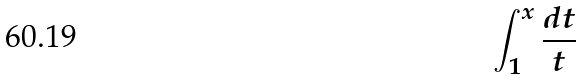Convert formula to latex. <formula><loc_0><loc_0><loc_500><loc_500>\int _ { 1 } ^ { x } \frac { d t } { t }</formula> 